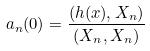<formula> <loc_0><loc_0><loc_500><loc_500>a _ { n } ( 0 ) = \frac { ( h ( x ) , X _ { n } ) } { ( X _ { n } , X _ { n } ) }</formula> 